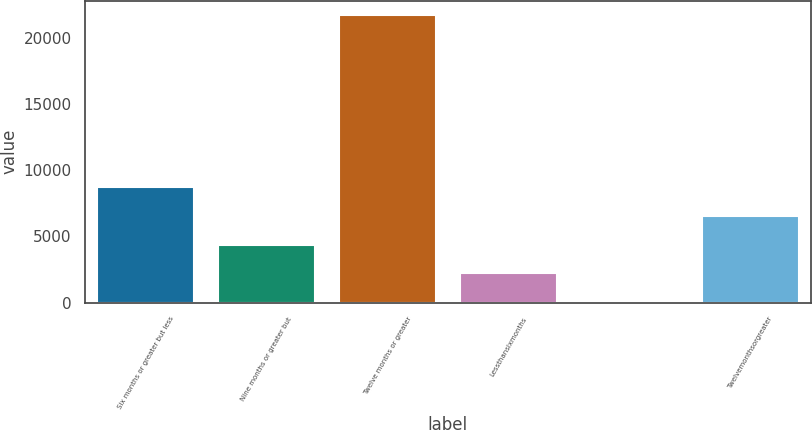<chart> <loc_0><loc_0><loc_500><loc_500><bar_chart><fcel>Six months or greater but less<fcel>Nine months or greater but<fcel>Twelve months or greater<fcel>Lessthansixmonths<fcel>Unnamed: 4<fcel>Twelvemonthsorgreater<nl><fcel>8705.8<fcel>4367.4<fcel>21721<fcel>2198.2<fcel>29<fcel>6536.6<nl></chart> 